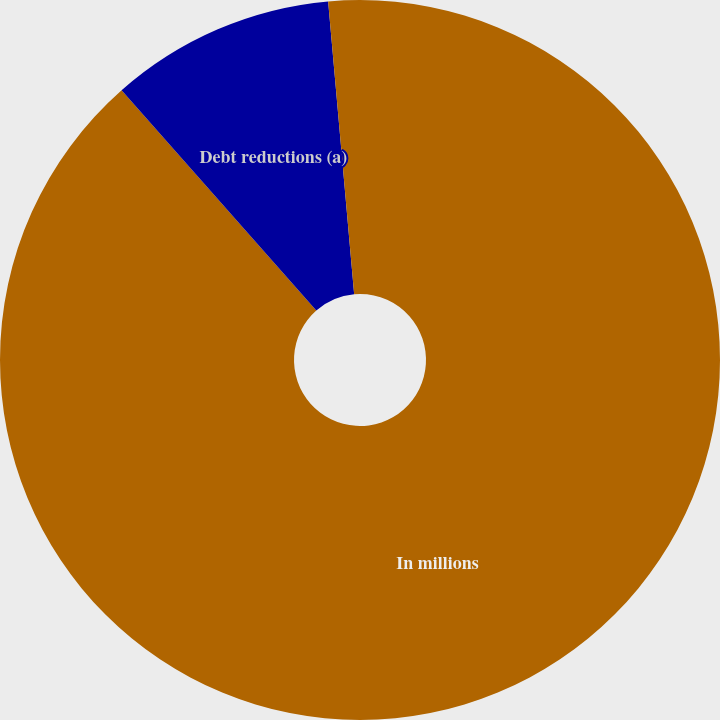Convert chart to OTSL. <chart><loc_0><loc_0><loc_500><loc_500><pie_chart><fcel>In millions<fcel>Debt reductions (a)<fcel>Pre-tax early debt<nl><fcel>88.48%<fcel>10.11%<fcel>1.41%<nl></chart> 